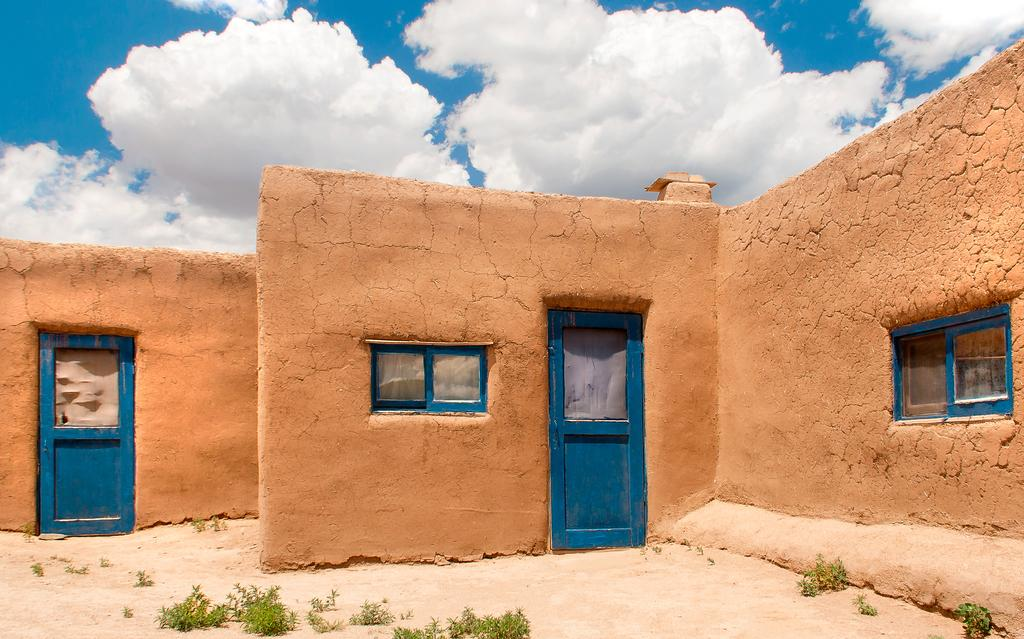What type of structures can be seen on the walls in the image? There are doors and windows on the walls in the image. What is in front of the walls? Plants are visible in front of the walls. What is visible at the top of the image? The sky is clear and visible at the top of the image. What arithmetic problem is being solved on the wall in the image? There is no arithmetic problem visible on the wall in the image. Can you tell me the rate at which the plane is flying in the image? There is no plane present in the image, so it is not possible to determine the rate at which it might be flying. 